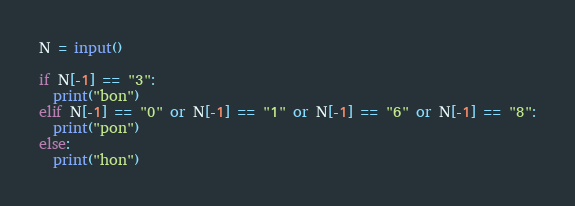<code> <loc_0><loc_0><loc_500><loc_500><_Python_>N = input()

if N[-1] == "3":
  print("bon")
elif N[-1] == "0" or N[-1] == "1" or N[-1] == "6" or N[-1] == "8":
  print("pon")
else:
  print("hon")</code> 